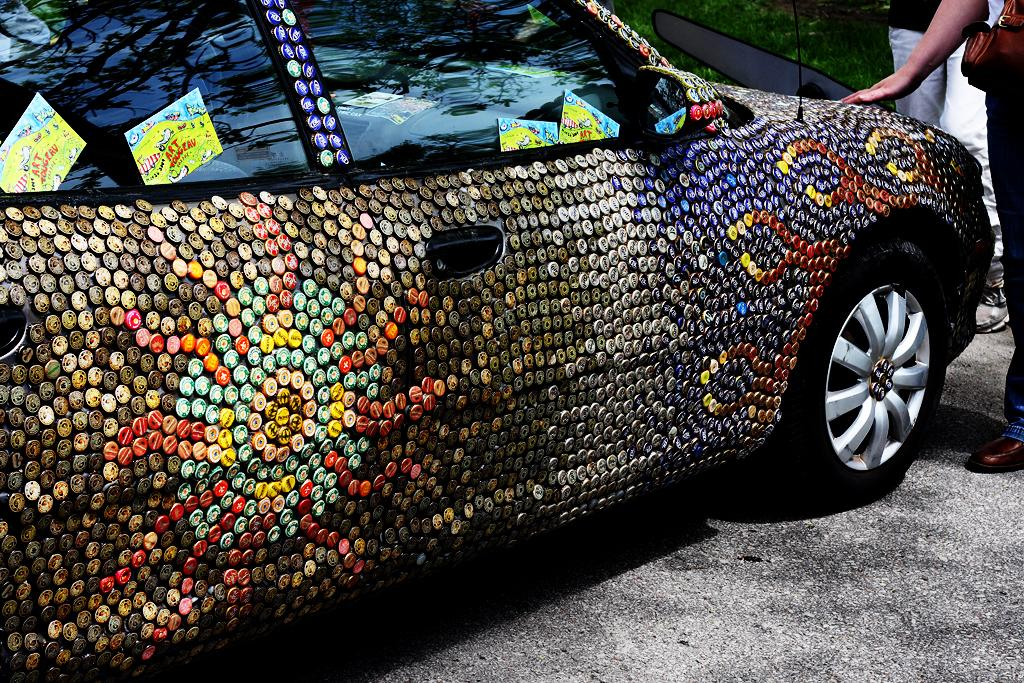What is the main subject of the image? The main subject of the image is a car. Where is the car located in the image? The car is parked on the road in the image. What can be seen on the car? There are badges on the car. Is there anyone near the car in the image? Yes, there is a woman standing near the car. What type of cloth is draped over the jellyfish in the image? There is no jellyfish present in the image; it features a car parked on the road with a woman standing nearby. 